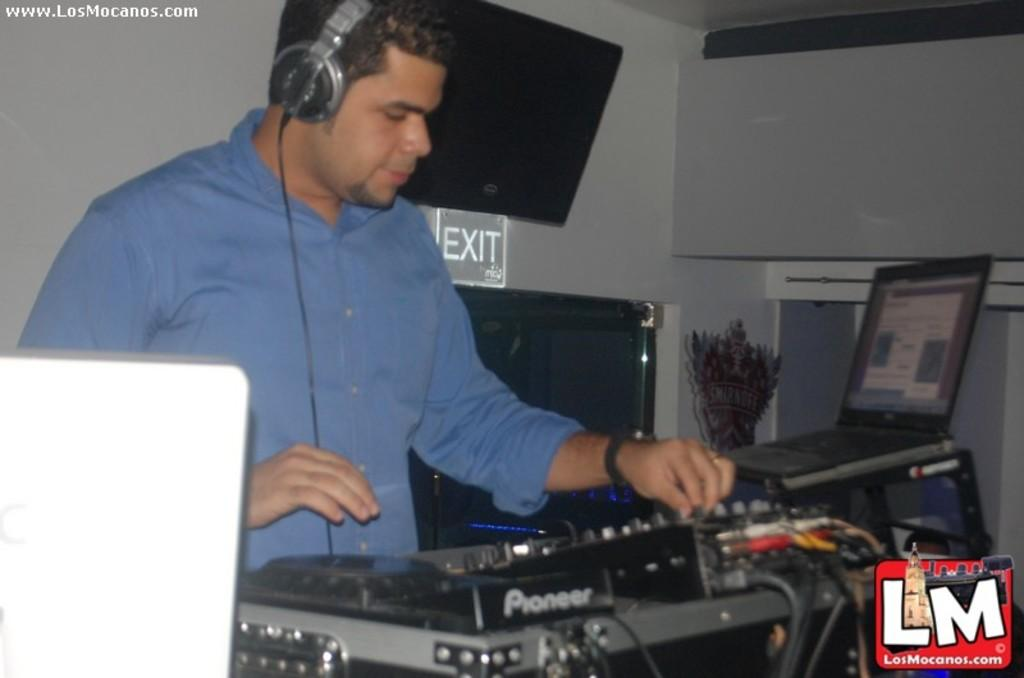<image>
Share a concise interpretation of the image provided. A man standing at an audio deck in front of an exit sign. 